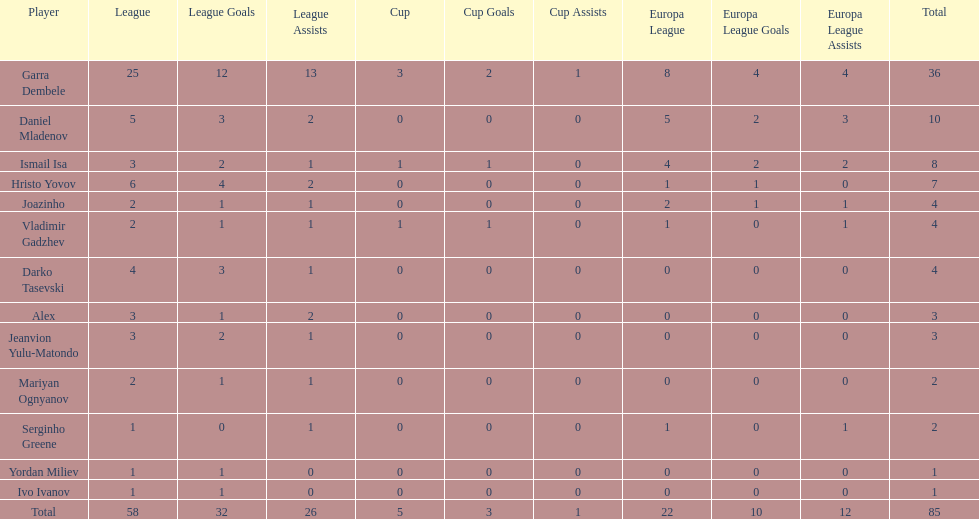Who had the most goal scores? Garra Dembele. 